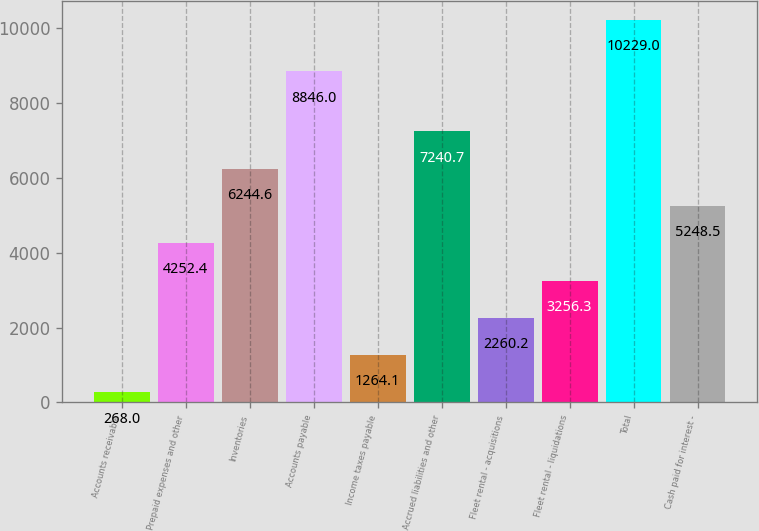Convert chart to OTSL. <chart><loc_0><loc_0><loc_500><loc_500><bar_chart><fcel>Accounts receivable<fcel>Prepaid expenses and other<fcel>Inventories<fcel>Accounts payable<fcel>Income taxes payable<fcel>Accrued liabilities and other<fcel>Fleet rental - acquisitions<fcel>Fleet rental - liquidations<fcel>Total<fcel>Cash paid for interest -<nl><fcel>268<fcel>4252.4<fcel>6244.6<fcel>8846<fcel>1264.1<fcel>7240.7<fcel>2260.2<fcel>3256.3<fcel>10229<fcel>5248.5<nl></chart> 